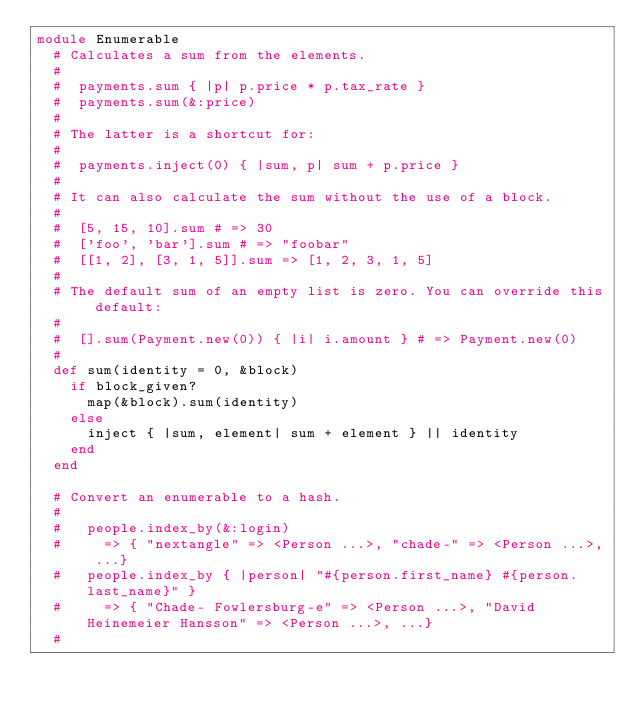<code> <loc_0><loc_0><loc_500><loc_500><_Ruby_>module Enumerable
  # Calculates a sum from the elements.
  #
  #  payments.sum { |p| p.price * p.tax_rate }
  #  payments.sum(&:price)
  #
  # The latter is a shortcut for:
  #
  #  payments.inject(0) { |sum, p| sum + p.price }
  #
  # It can also calculate the sum without the use of a block.
  #
  #  [5, 15, 10].sum # => 30
  #  ['foo', 'bar'].sum # => "foobar"
  #  [[1, 2], [3, 1, 5]].sum => [1, 2, 3, 1, 5]
  #
  # The default sum of an empty list is zero. You can override this default:
  #
  #  [].sum(Payment.new(0)) { |i| i.amount } # => Payment.new(0)
  #
  def sum(identity = 0, &block)
    if block_given?
      map(&block).sum(identity)
    else
      inject { |sum, element| sum + element } || identity
    end
  end

  # Convert an enumerable to a hash.
  #
  #   people.index_by(&:login)
  #     => { "nextangle" => <Person ...>, "chade-" => <Person ...>, ...}
  #   people.index_by { |person| "#{person.first_name} #{person.last_name}" }
  #     => { "Chade- Fowlersburg-e" => <Person ...>, "David Heinemeier Hansson" => <Person ...>, ...}
  #</code> 